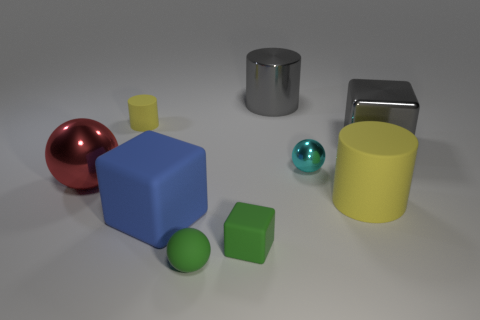How many big green spheres are there?
Your answer should be very brief. 0. Are there any other large metallic cubes of the same color as the metal block?
Provide a short and direct response. No. What is the color of the block on the right side of the yellow cylinder to the right of the big block that is in front of the gray cube?
Offer a very short reply. Gray. Is the tiny green cube made of the same material as the yellow thing on the left side of the green matte ball?
Your answer should be very brief. Yes. What is the material of the small green cube?
Ensure brevity in your answer.  Rubber. There is a small object that is the same color as the rubber ball; what is its material?
Offer a very short reply. Rubber. How many other things are there of the same material as the big red object?
Offer a very short reply. 3. The rubber object that is both behind the blue cube and left of the cyan thing has what shape?
Your response must be concise. Cylinder. There is a tiny object that is made of the same material as the red sphere; what is its color?
Make the answer very short. Cyan. Are there an equal number of small cyan objects that are to the right of the gray cylinder and yellow metallic balls?
Make the answer very short. No. 